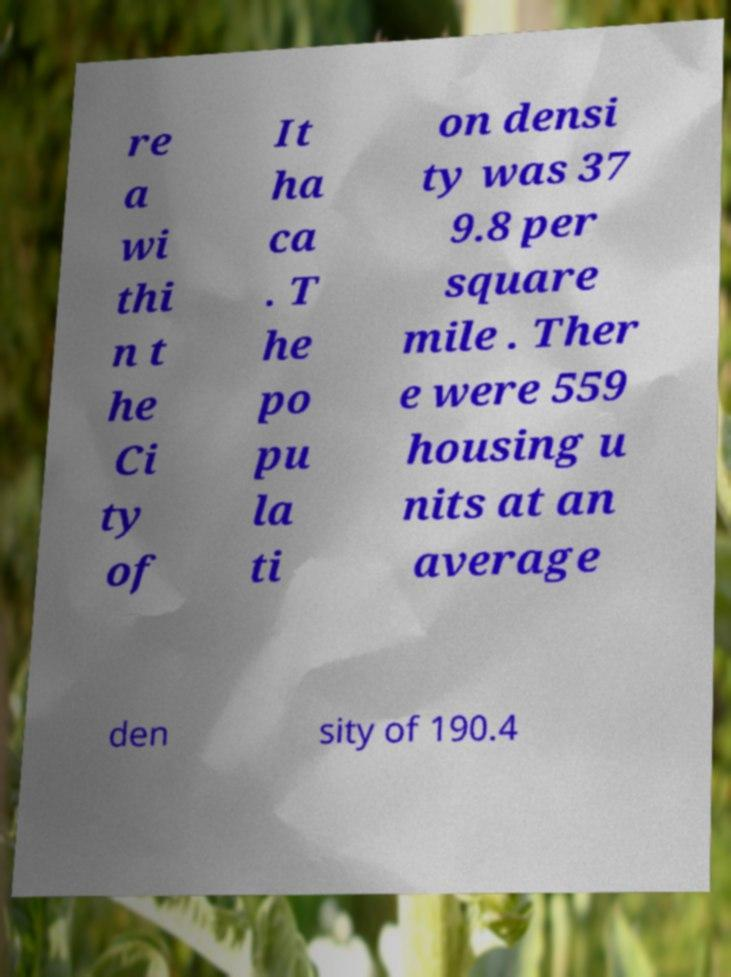Please read and relay the text visible in this image. What does it say? re a wi thi n t he Ci ty of It ha ca . T he po pu la ti on densi ty was 37 9.8 per square mile . Ther e were 559 housing u nits at an average den sity of 190.4 